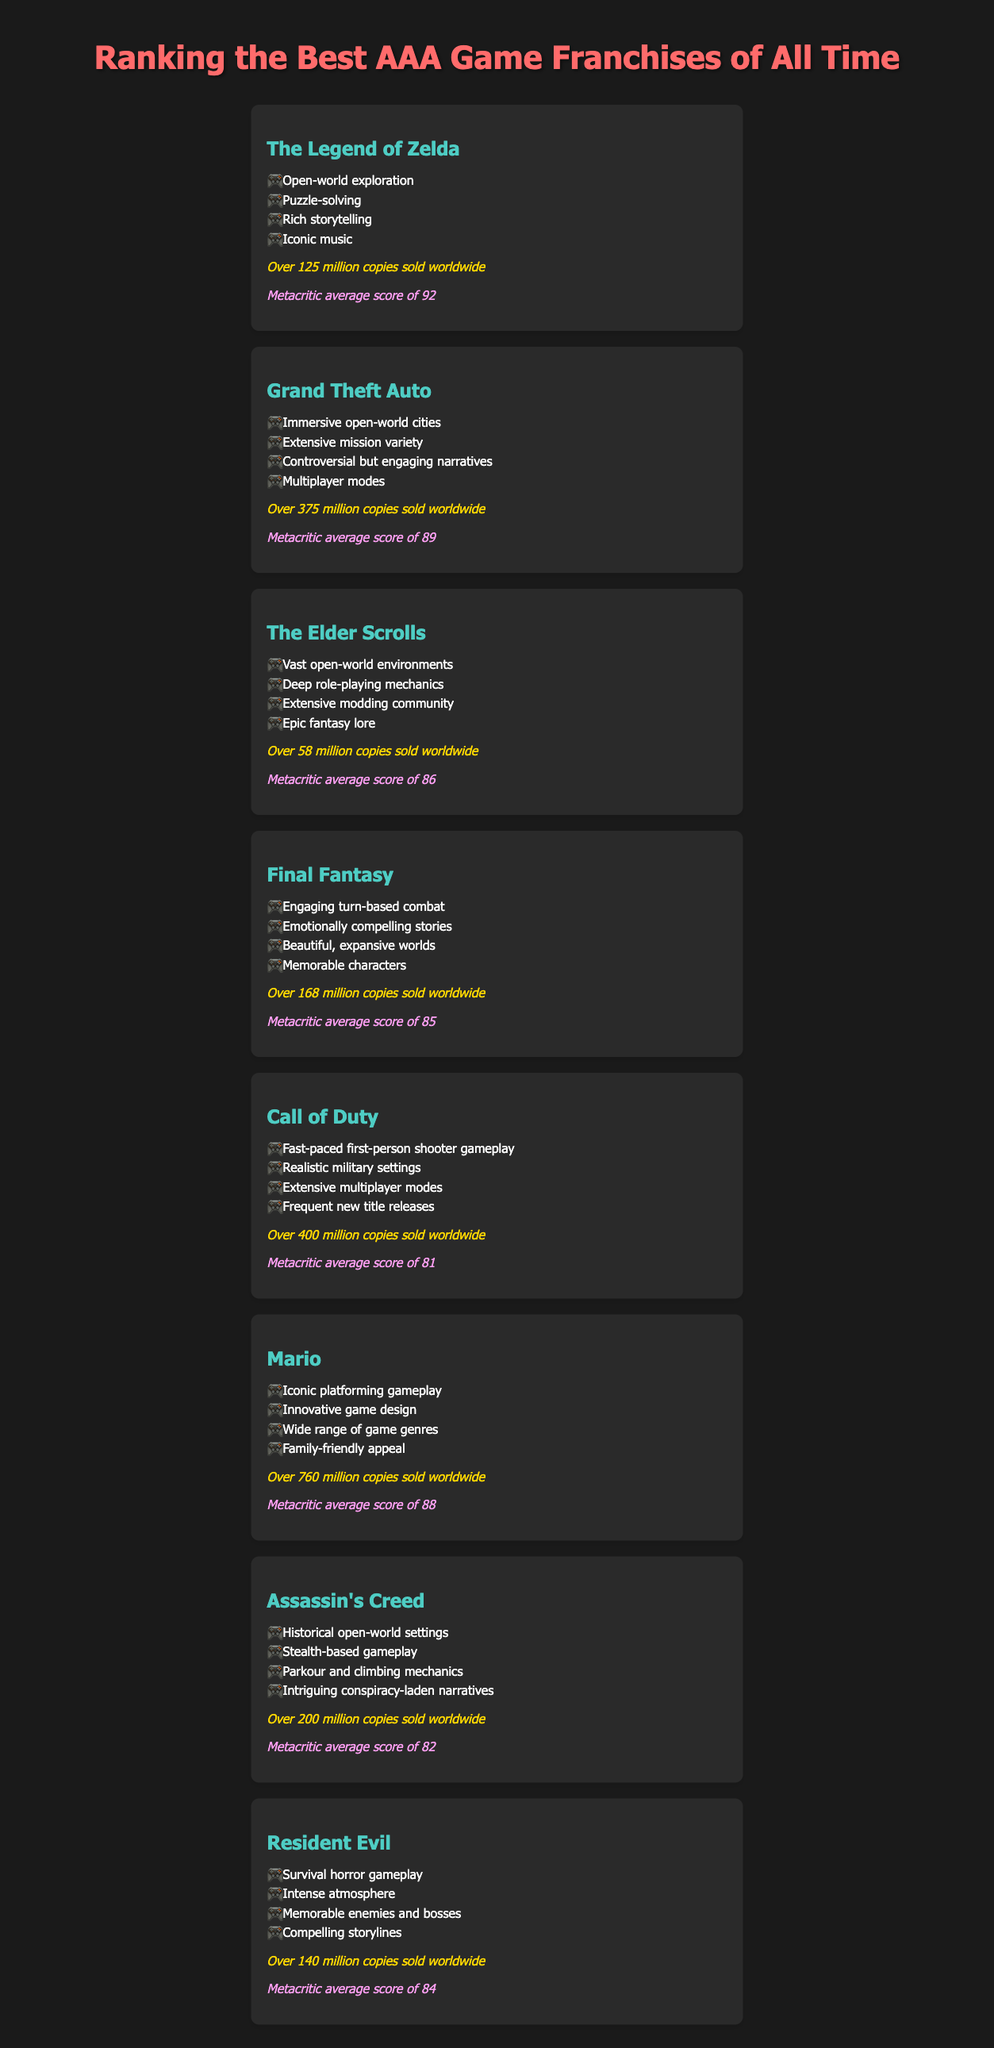What game franchise has the highest sales? The highest sales can be determined by comparing the sales figures for each franchise listed. Mario has over 760 million copies sold, the highest among them.
Answer: Over 760 million copies What is the average Metacritic score for Grand Theft Auto? The average Metacritic score for Grand Theft Auto is specified in the document, which is 89.
Answer: 89 Which franchise features historical open-world settings? Identifying the franchise that includes this feature can be done by looking at the feature list of each franchise. Assassin's Creed is noted for this.
Answer: Assassin's Creed How many million sales does The Elder Scrolls have? The Elder Scrolls has a specific sales figure mentioned in the document which is over 58 million copies.
Answer: Over 58 million copies What is the primary gameplay mechanics for Resident Evil? The document lists various gameplay features; for Resident Evil, survival horror gameplay is highlighted as a key aspect.
Answer: Survival horror gameplay Which franchise has the lowest average rating on Metacritic? Comparing the average Metacritic scores provided in the document shows that Call of Duty has the lowest score of 81.
Answer: 81 What notable feature does Final Fantasy offer? The notable features are listed for each franchise; engaging turn-based combat is a highlighted feature for Final Fantasy.
Answer: Engaging turn-based combat How many copies has Call of Duty sold worldwide? The document specifies that Call of Duty has sold over 400 million copies worldwide.
Answer: Over 400 million copies Which franchise is known for its iconic music? The document mentions that The Legend of Zelda is recognized for its iconic music among other features.
Answer: The Legend of Zelda 